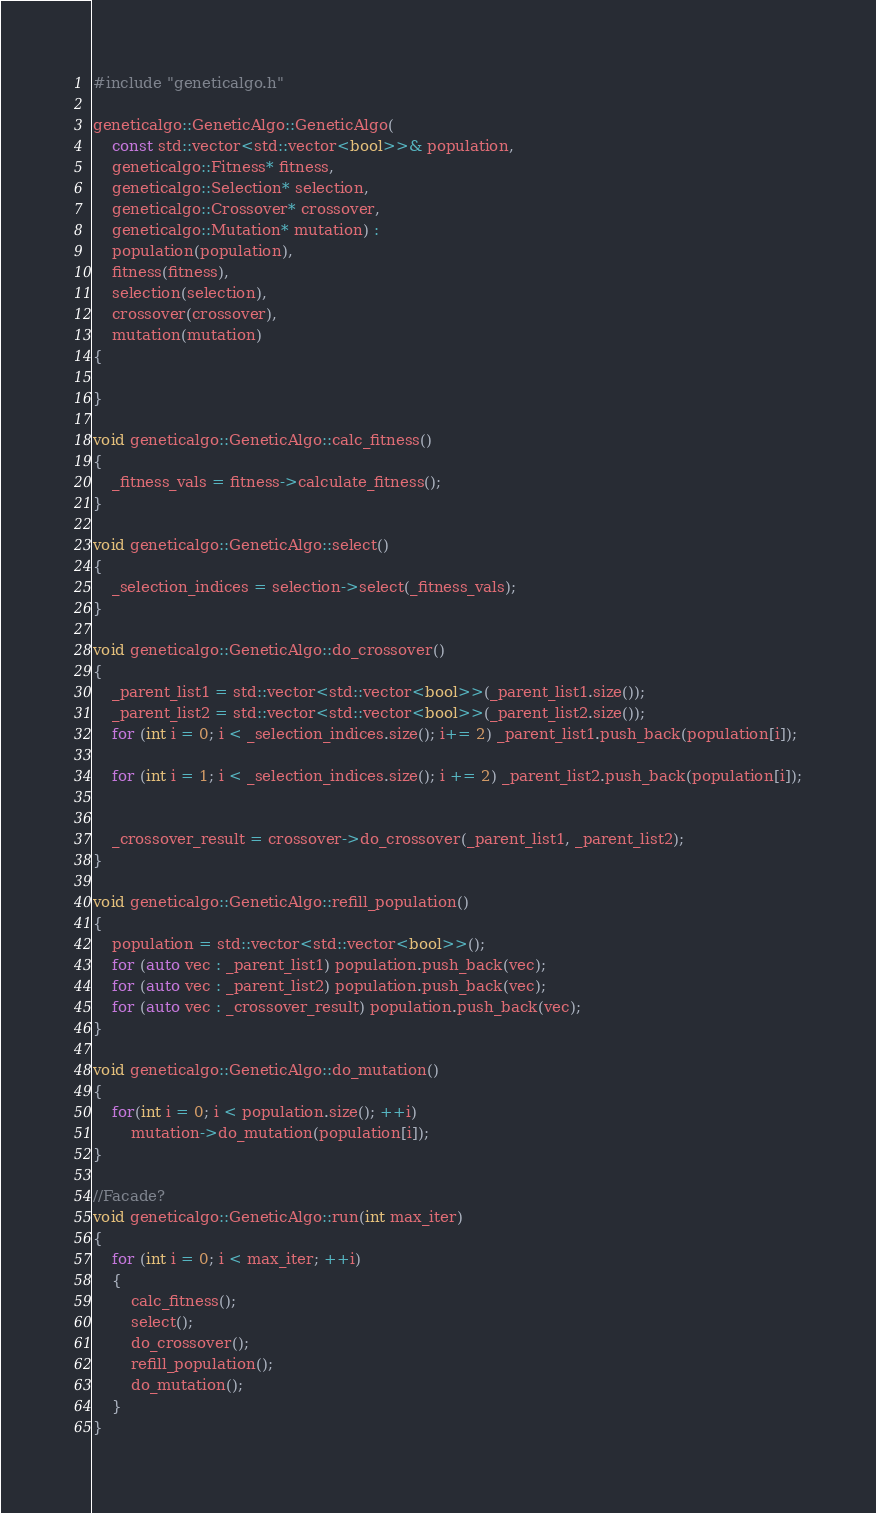<code> <loc_0><loc_0><loc_500><loc_500><_C++_>#include "geneticalgo.h"

geneticalgo::GeneticAlgo::GeneticAlgo(
	const std::vector<std::vector<bool>>& population,
	geneticalgo::Fitness* fitness,
	geneticalgo::Selection* selection,
	geneticalgo::Crossover* crossover,
	geneticalgo::Mutation* mutation) :
	population(population),
	fitness(fitness),
	selection(selection),
	crossover(crossover),
	mutation(mutation)
{

}

void geneticalgo::GeneticAlgo::calc_fitness()
{
	_fitness_vals = fitness->calculate_fitness();
}

void geneticalgo::GeneticAlgo::select()
{
	_selection_indices = selection->select(_fitness_vals);
}

void geneticalgo::GeneticAlgo::do_crossover()
{
	_parent_list1 = std::vector<std::vector<bool>>(_parent_list1.size());
	_parent_list2 = std::vector<std::vector<bool>>(_parent_list2.size());
	for (int i = 0; i < _selection_indices.size(); i+= 2) _parent_list1.push_back(population[i]);

	for (int i = 1; i < _selection_indices.size(); i += 2) _parent_list2.push_back(population[i]);


	_crossover_result = crossover->do_crossover(_parent_list1, _parent_list2);
}

void geneticalgo::GeneticAlgo::refill_population()
{
	population = std::vector<std::vector<bool>>();
	for (auto vec : _parent_list1) population.push_back(vec);
	for (auto vec : _parent_list2) population.push_back(vec);
	for (auto vec : _crossover_result) population.push_back(vec);
}

void geneticalgo::GeneticAlgo::do_mutation()
{
	for(int i = 0; i < population.size(); ++i)
		mutation->do_mutation(population[i]);
}

//Facade?
void geneticalgo::GeneticAlgo::run(int max_iter)
{
	for (int i = 0; i < max_iter; ++i)
	{
		calc_fitness();
		select();
		do_crossover();
		refill_population();
		do_mutation();
	}
}

</code> 